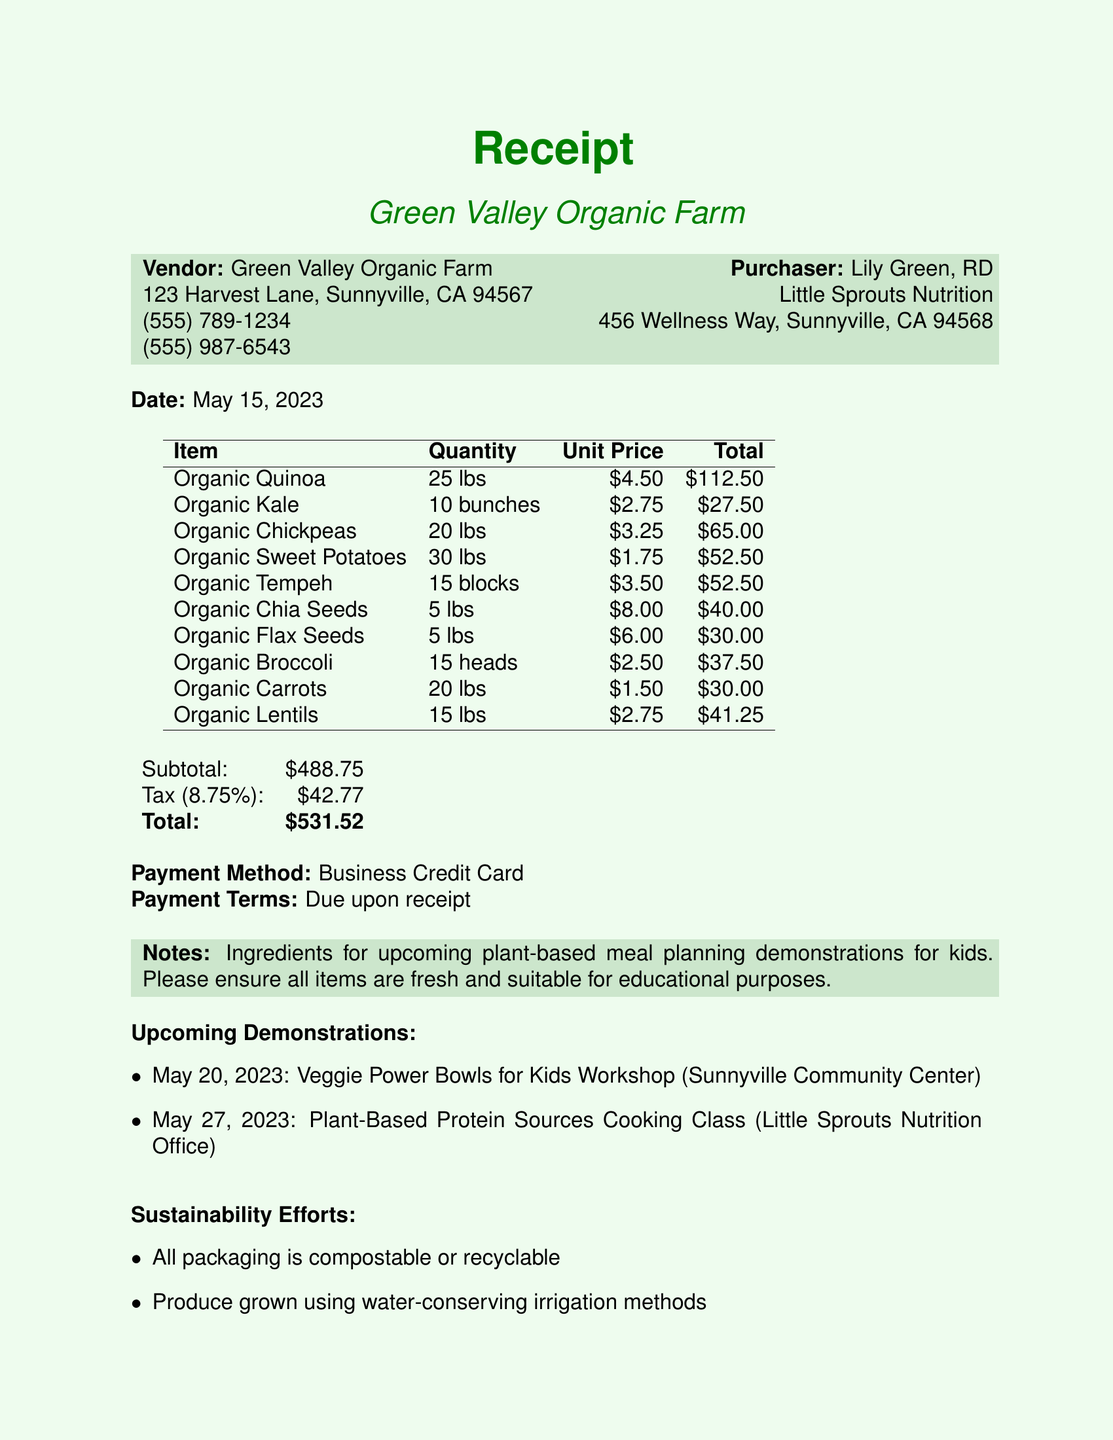what is the vendor name? The vendor name can be found at the top of the receipt and is Green Valley Organic Farm.
Answer: Green Valley Organic Farm what is the total amount due? The total amount due is listed at the end of the receipt as the final amount that needs to be paid.
Answer: $531.52 who is the purchaser? The purchaser's name is indicated on the receipt as the individual or business that bought the items.
Answer: Lily Green, RD what is the date of the purchase? The date of the purchase is clearly stated in the document, reflecting when the transaction took place.
Answer: May 15, 2023 how many heads of organic broccoli were purchased? The quantity of organic broccoli purchased is specified in the item list of the receipt.
Answer: 15 heads when is the Veggie Power Bowls for Kids Workshop scheduled? The date for the workshop can be found in the upcoming demonstrations section of the receipt.
Answer: May 20, 2023 how much did the organic kale cost? The cost of organic kale is included in the itemized list along with its quantity and unit price.
Answer: $27.50 what payment method was used? The document specifies the method of payment used for the transaction in the relevant section.
Answer: Business Credit Card what is one sustainability effort mentioned? The document includes a list of sustainability efforts made by the vendor.
Answer: All packaging is compostable or recyclable 